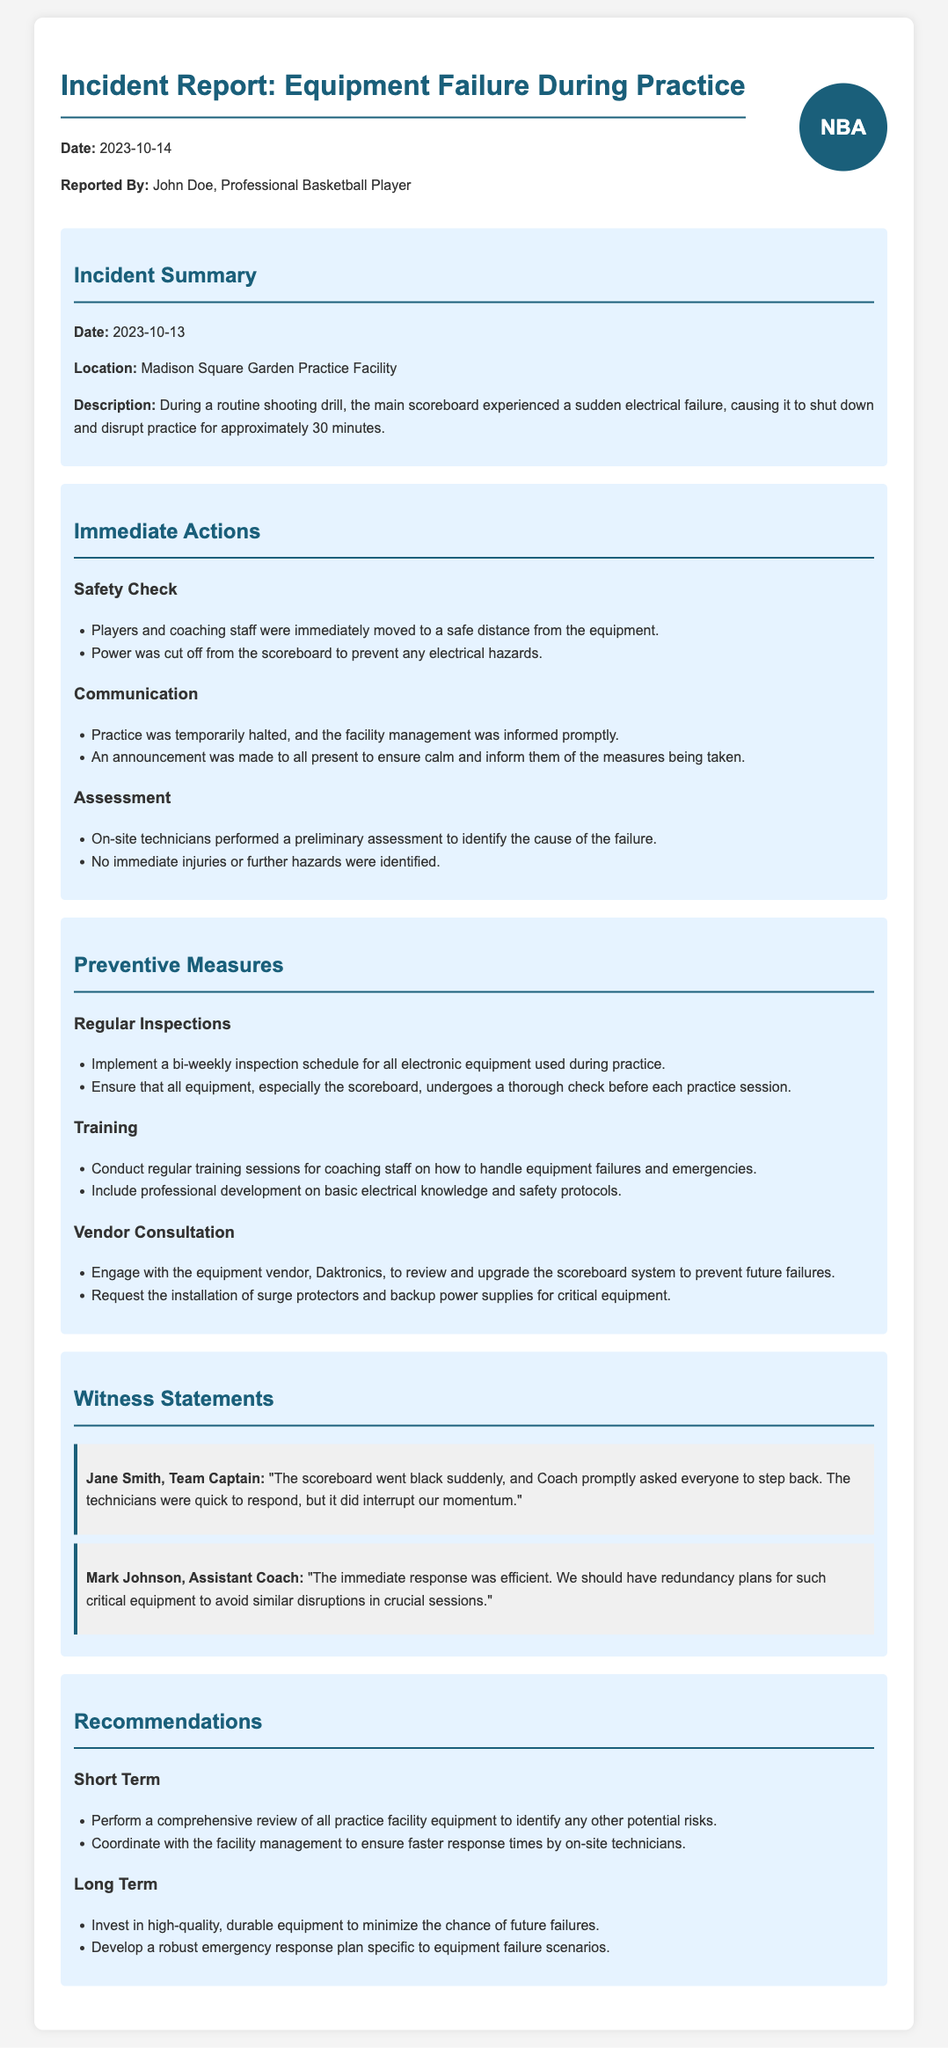What was the date of the incident? The date of the incident is mentioned in the incident summary section of the document.
Answer: 2023-10-13 Who reported the incident? The report includes the name of the individual who submitted the report.
Answer: John Doe What location did the incident occur at? The location of the incident is specified in the incident summary section.
Answer: Madison Square Garden Practice Facility How long was the practice disrupted? The duration of the disruption caused by the incident is provided in the incident summary.
Answer: 30 minutes What immediate action was taken first? The immediate actions section details the steps taken immediately after the incident occurred.
Answer: Players and coaching staff were immediately moved to a safe distance from the equipment What preventive measure involves training? The preventive measures section lists actions to ensure readiness for future incidents.
Answer: Conduct regular training sessions for coaching staff on how to handle equipment failures and emergencies Which vendor is mentioned for consultation? The document identifies a specific vendor recommended for consultation regarding equipment.
Answer: Daktronics What type of plan is suggested for long term? The recommendations section includes strategies for future preparations in response to incidents.
Answer: Develop a robust emergency response plan specific to equipment failure scenarios What was a witness's response to the immediate actions? The witness statements section captures observations of those present during the incident.
Answer: The immediate response was efficient 